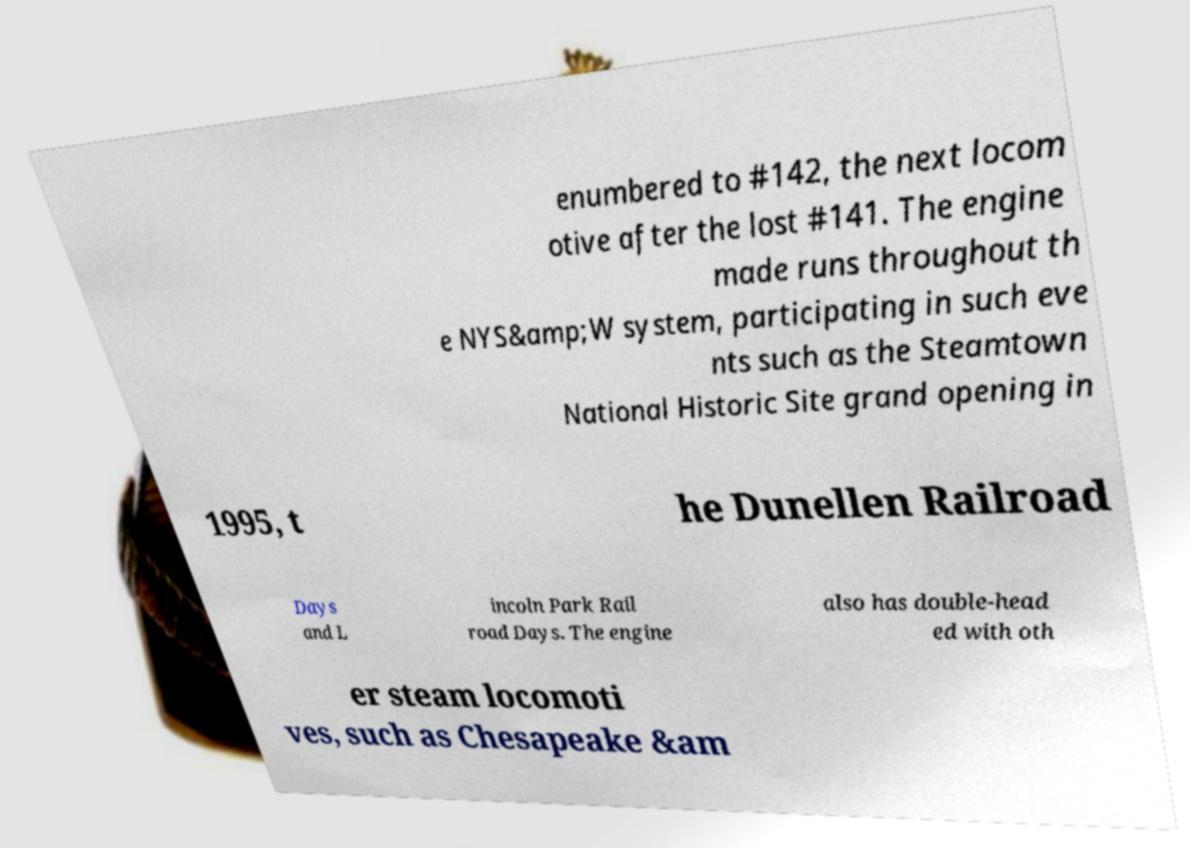Could you extract and type out the text from this image? enumbered to #142, the next locom otive after the lost #141. The engine made runs throughout th e NYS&amp;W system, participating in such eve nts such as the Steamtown National Historic Site grand opening in 1995, t he Dunellen Railroad Days and L incoln Park Rail road Days. The engine also has double-head ed with oth er steam locomoti ves, such as Chesapeake &am 